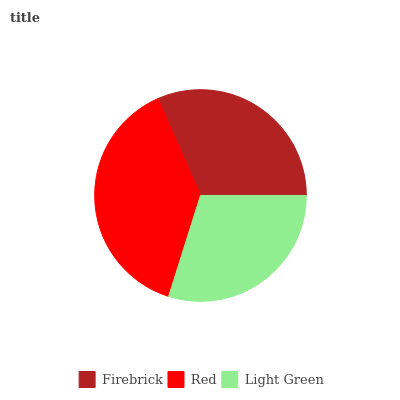Is Light Green the minimum?
Answer yes or no. Yes. Is Red the maximum?
Answer yes or no. Yes. Is Red the minimum?
Answer yes or no. No. Is Light Green the maximum?
Answer yes or no. No. Is Red greater than Light Green?
Answer yes or no. Yes. Is Light Green less than Red?
Answer yes or no. Yes. Is Light Green greater than Red?
Answer yes or no. No. Is Red less than Light Green?
Answer yes or no. No. Is Firebrick the high median?
Answer yes or no. Yes. Is Firebrick the low median?
Answer yes or no. Yes. Is Red the high median?
Answer yes or no. No. Is Red the low median?
Answer yes or no. No. 